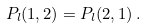Convert formula to latex. <formula><loc_0><loc_0><loc_500><loc_500>P _ { l } ( 1 , 2 ) = P _ { l } ( 2 , 1 ) \, .</formula> 